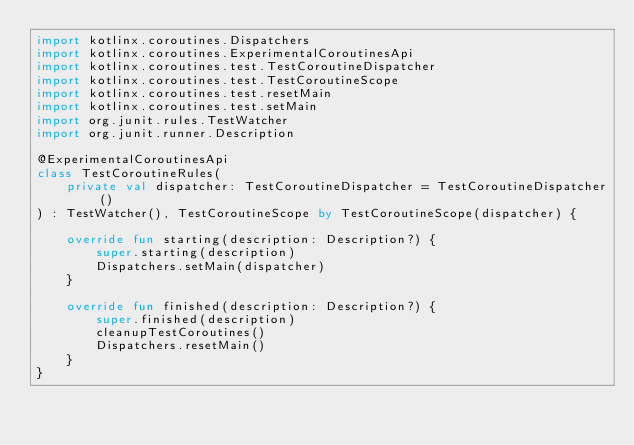Convert code to text. <code><loc_0><loc_0><loc_500><loc_500><_Kotlin_>import kotlinx.coroutines.Dispatchers
import kotlinx.coroutines.ExperimentalCoroutinesApi
import kotlinx.coroutines.test.TestCoroutineDispatcher
import kotlinx.coroutines.test.TestCoroutineScope
import kotlinx.coroutines.test.resetMain
import kotlinx.coroutines.test.setMain
import org.junit.rules.TestWatcher
import org.junit.runner.Description

@ExperimentalCoroutinesApi
class TestCoroutineRules(
    private val dispatcher: TestCoroutineDispatcher = TestCoroutineDispatcher()
) : TestWatcher(), TestCoroutineScope by TestCoroutineScope(dispatcher) {

    override fun starting(description: Description?) {
        super.starting(description)
        Dispatchers.setMain(dispatcher)
    }

    override fun finished(description: Description?) {
        super.finished(description)
        cleanupTestCoroutines()
        Dispatchers.resetMain()
    }
}</code> 